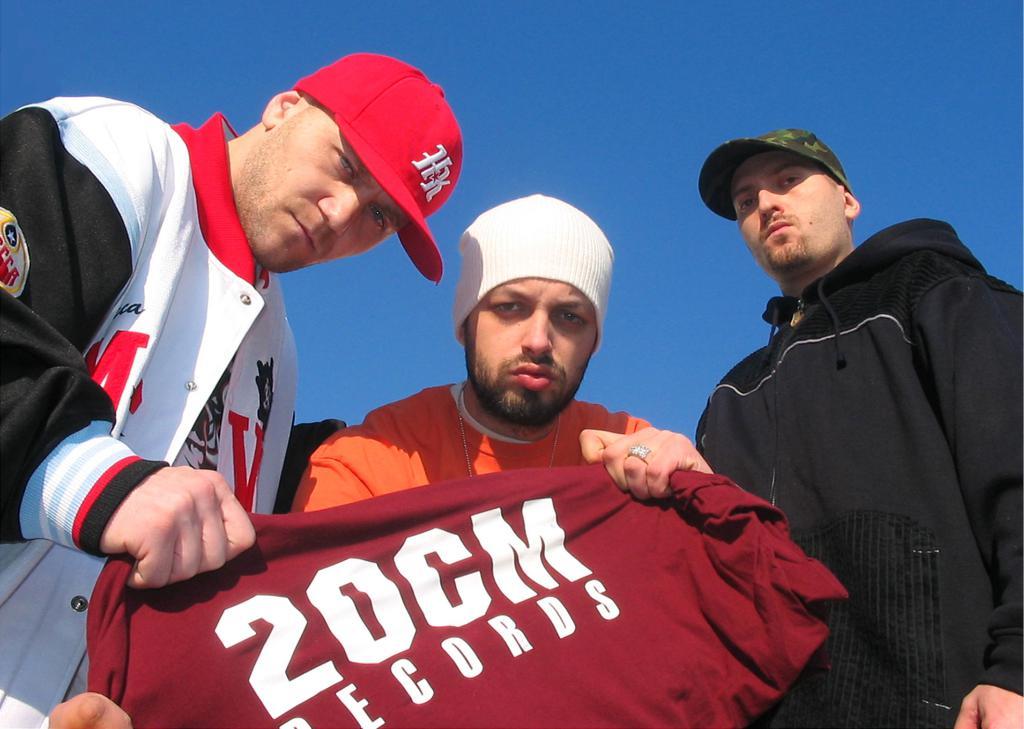Is that 20cm?
Provide a short and direct response. Yes. Yes tshirt print?
Offer a terse response. Yes. 